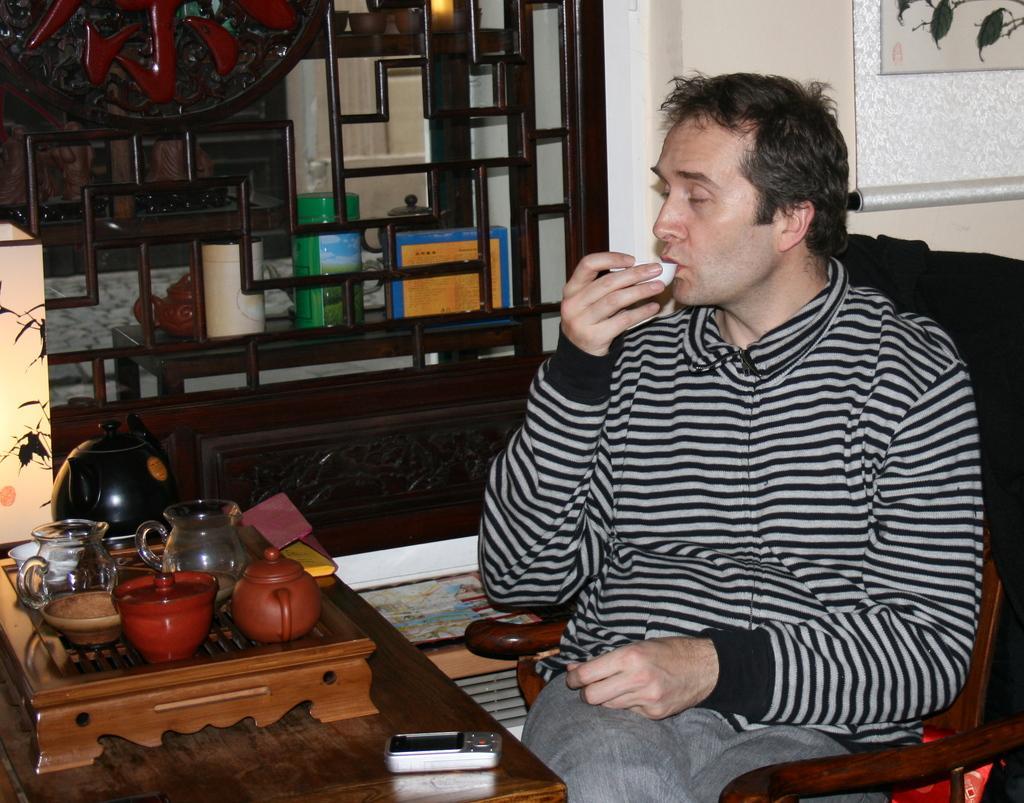Please provide a concise description of this image. In the image we can see there is a person who is sitting on chair and he is holding a bowl in his hand and on table there is kettle, jug, bowl and camera. On the other side there is table on which there are book and other bottle. 